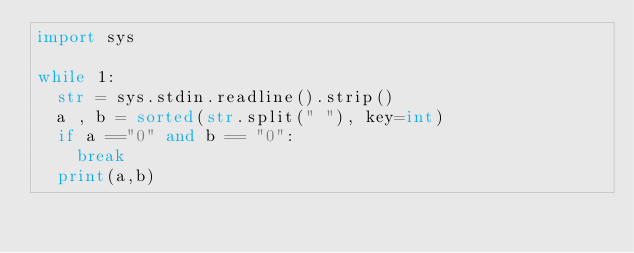<code> <loc_0><loc_0><loc_500><loc_500><_Python_>import sys

while 1:
  str = sys.stdin.readline().strip()
  a , b = sorted(str.split(" "), key=int)
  if a =="0" and b == "0":
    break
  print(a,b)</code> 